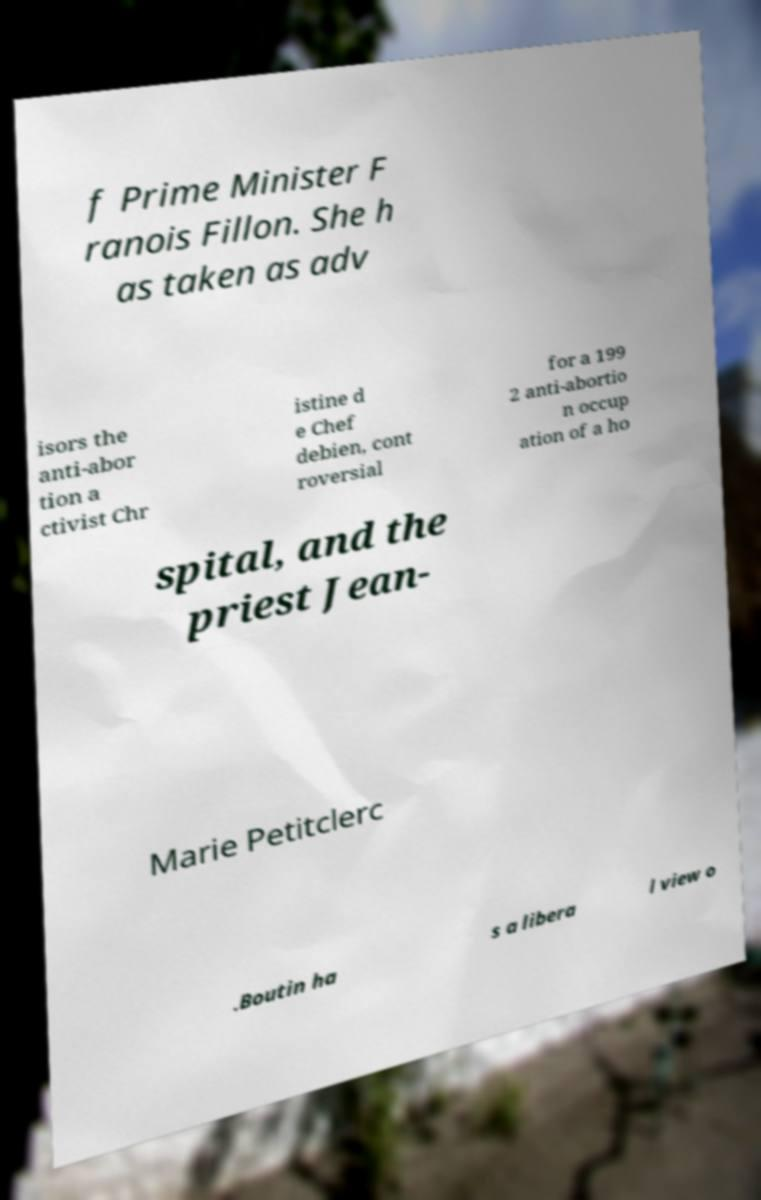Please read and relay the text visible in this image. What does it say? f Prime Minister F ranois Fillon. She h as taken as adv isors the anti-abor tion a ctivist Chr istine d e Chef debien, cont roversial for a 199 2 anti-abortio n occup ation of a ho spital, and the priest Jean- Marie Petitclerc .Boutin ha s a libera l view o 